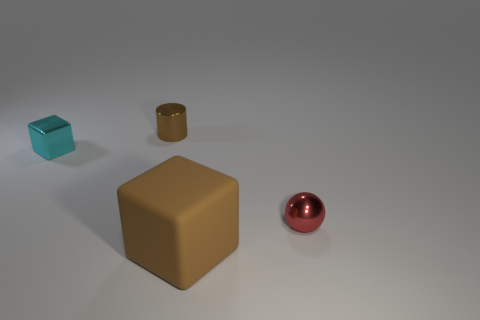Add 2 metal spheres. How many objects exist? 6 Subtract all cylinders. How many objects are left? 3 Add 4 brown metal cylinders. How many brown metal cylinders are left? 5 Add 4 tiny brown shiny things. How many tiny brown shiny things exist? 5 Subtract 0 yellow blocks. How many objects are left? 4 Subtract all brown matte objects. Subtract all small red metal things. How many objects are left? 2 